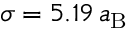Convert formula to latex. <formula><loc_0><loc_0><loc_500><loc_500>\sigma = 5 . 1 9 \, a _ { B }</formula> 